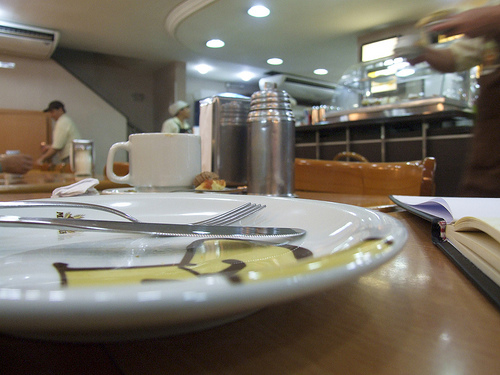<image>
Can you confirm if the table is under the light? Yes. The table is positioned underneath the light, with the light above it in the vertical space. 